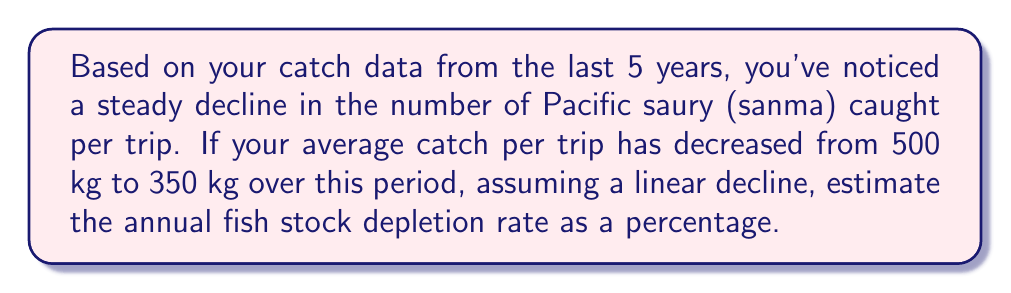Give your solution to this math problem. Let's approach this step-by-step:

1) First, we need to calculate the total decrease in catch over the 5-year period:
   $500 \text{ kg} - 350 \text{ kg} = 150 \text{ kg}$

2) To find the annual decrease, we divide this by the number of years:
   $\frac{150 \text{ kg}}{5 \text{ years}} = 30 \text{ kg/year}$

3) To express this as a percentage of the original stock, we divide by the original catch and multiply by 100:
   $$\text{Annual depletion rate} = \frac{30 \text{ kg/year}}{500 \text{ kg}} \times 100\% = 0.06 \times 100\% = 6\%$$

4) Therefore, the estimated annual fish stock depletion rate is 6%.

This method assumes a linear decline in fish stock, which is a simplification. In reality, fish population dynamics can be more complex, influenced by factors such as reproduction rates, environmental conditions, and fishing practices. However, this linear approximation can provide a useful estimate for short-term trends.
Answer: 6% 